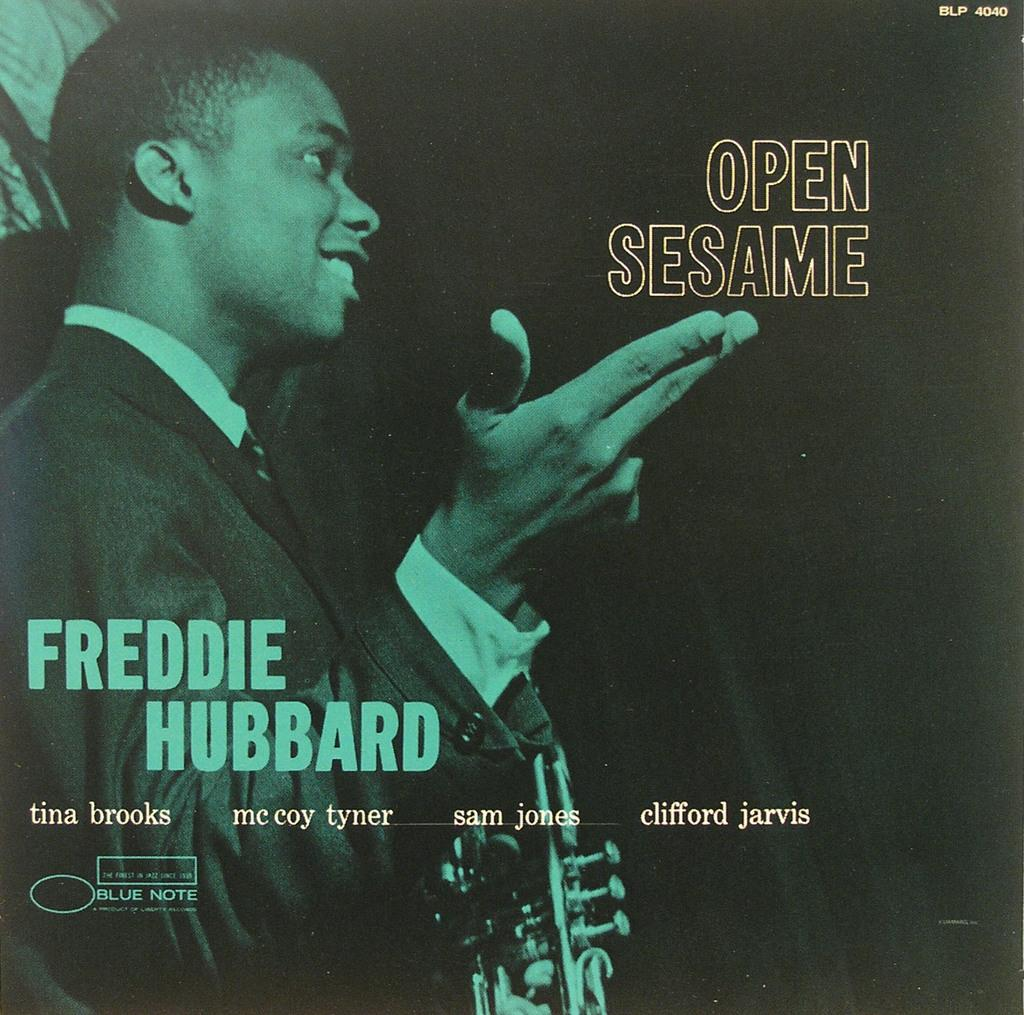<image>
Create a compact narrative representing the image presented. The name of the album is Open Sesame by Freddie Hubbard. 